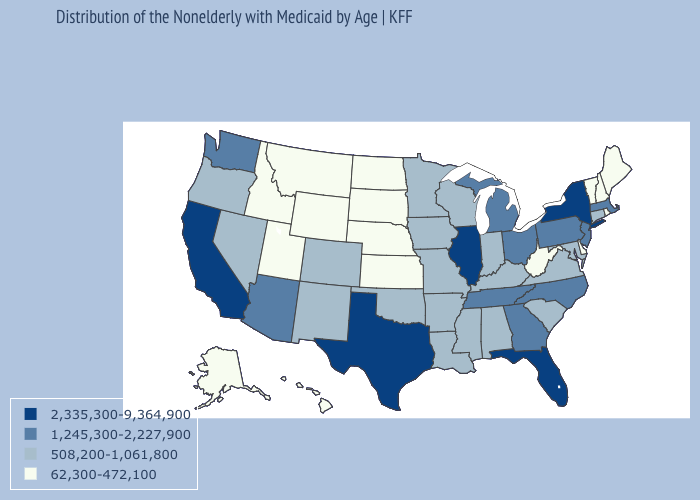Among the states that border Indiana , does Michigan have the lowest value?
Answer briefly. No. Among the states that border Maryland , does Pennsylvania have the highest value?
Write a very short answer. Yes. What is the value of Illinois?
Write a very short answer. 2,335,300-9,364,900. What is the value of New Mexico?
Be succinct. 508,200-1,061,800. Which states have the highest value in the USA?
Keep it brief. California, Florida, Illinois, New York, Texas. What is the lowest value in the USA?
Write a very short answer. 62,300-472,100. What is the lowest value in states that border North Carolina?
Concise answer only. 508,200-1,061,800. Name the states that have a value in the range 2,335,300-9,364,900?
Write a very short answer. California, Florida, Illinois, New York, Texas. What is the lowest value in the USA?
Keep it brief. 62,300-472,100. Name the states that have a value in the range 1,245,300-2,227,900?
Short answer required. Arizona, Georgia, Massachusetts, Michigan, New Jersey, North Carolina, Ohio, Pennsylvania, Tennessee, Washington. Name the states that have a value in the range 508,200-1,061,800?
Short answer required. Alabama, Arkansas, Colorado, Connecticut, Indiana, Iowa, Kentucky, Louisiana, Maryland, Minnesota, Mississippi, Missouri, Nevada, New Mexico, Oklahoma, Oregon, South Carolina, Virginia, Wisconsin. Name the states that have a value in the range 508,200-1,061,800?
Quick response, please. Alabama, Arkansas, Colorado, Connecticut, Indiana, Iowa, Kentucky, Louisiana, Maryland, Minnesota, Mississippi, Missouri, Nevada, New Mexico, Oklahoma, Oregon, South Carolina, Virginia, Wisconsin. Which states have the highest value in the USA?
Answer briefly. California, Florida, Illinois, New York, Texas. What is the value of Pennsylvania?
Keep it brief. 1,245,300-2,227,900. 